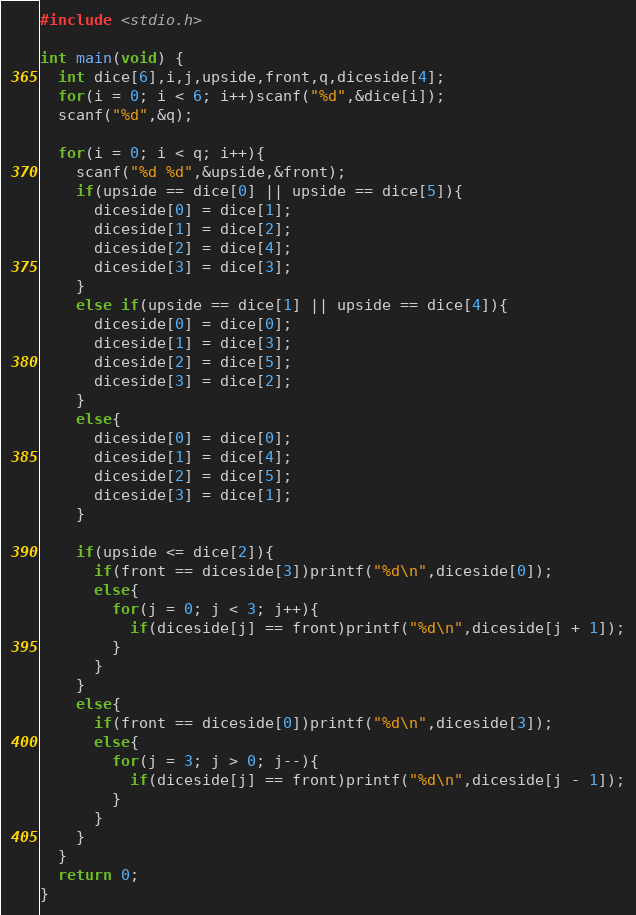Convert code to text. <code><loc_0><loc_0><loc_500><loc_500><_C_>#include <stdio.h>

int main(void) {
  int dice[6],i,j,upside,front,q,diceside[4];
  for(i = 0; i < 6; i++)scanf("%d",&dice[i]);
  scanf("%d",&q);

  for(i = 0; i < q; i++){
    scanf("%d %d",&upside,&front);
    if(upside == dice[0] || upside == dice[5]){
      diceside[0] = dice[1];
      diceside[1] = dice[2];
      diceside[2] = dice[4];
      diceside[3] = dice[3];
    }
    else if(upside == dice[1] || upside == dice[4]){
      diceside[0] = dice[0];
      diceside[1] = dice[3];
      diceside[2] = dice[5];
      diceside[3] = dice[2];
    }
    else{
      diceside[0] = dice[0];
      diceside[1] = dice[4];
      diceside[2] = dice[5];
      diceside[3] = dice[1]; 
    }

    if(upside <= dice[2]){
      if(front == diceside[3])printf("%d\n",diceside[0]);
      else{
        for(j = 0; j < 3; j++){
          if(diceside[j] == front)printf("%d\n",diceside[j + 1]);
        }
      }
    }
    else{
      if(front == diceside[0])printf("%d\n",diceside[3]);
      else{
        for(j = 3; j > 0; j--){
          if(diceside[j] == front)printf("%d\n",diceside[j - 1]);
        }
      }
    }
  }
  return 0;
}
</code> 